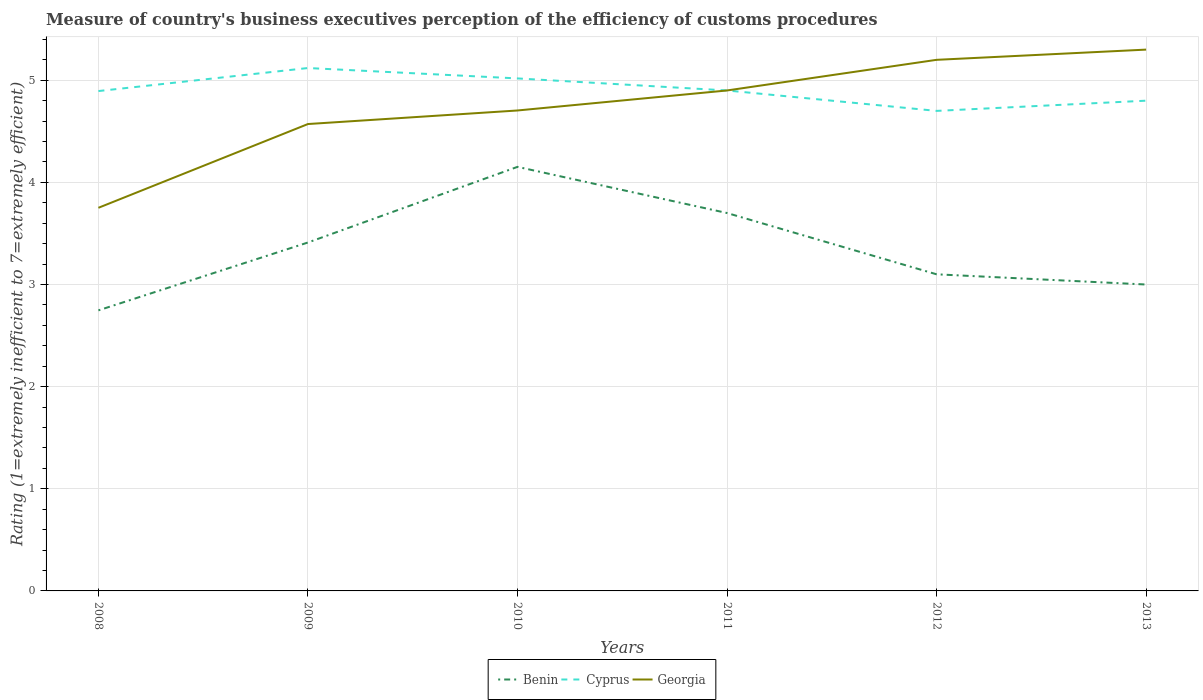Does the line corresponding to Georgia intersect with the line corresponding to Benin?
Your response must be concise. No. Across all years, what is the maximum rating of the efficiency of customs procedure in Benin?
Give a very brief answer. 2.75. In which year was the rating of the efficiency of customs procedure in Benin maximum?
Provide a short and direct response. 2008. What is the total rating of the efficiency of customs procedure in Cyprus in the graph?
Give a very brief answer. 0.32. What is the difference between the highest and the second highest rating of the efficiency of customs procedure in Georgia?
Give a very brief answer. 1.55. What is the difference between the highest and the lowest rating of the efficiency of customs procedure in Cyprus?
Your answer should be compact. 2. Is the rating of the efficiency of customs procedure in Cyprus strictly greater than the rating of the efficiency of customs procedure in Benin over the years?
Provide a short and direct response. No. How many lines are there?
Your response must be concise. 3. How many years are there in the graph?
Offer a terse response. 6. Are the values on the major ticks of Y-axis written in scientific E-notation?
Keep it short and to the point. No. Does the graph contain any zero values?
Offer a very short reply. No. What is the title of the graph?
Offer a terse response. Measure of country's business executives perception of the efficiency of customs procedures. Does "Nepal" appear as one of the legend labels in the graph?
Your answer should be compact. No. What is the label or title of the X-axis?
Provide a succinct answer. Years. What is the label or title of the Y-axis?
Offer a terse response. Rating (1=extremely inefficient to 7=extremely efficient). What is the Rating (1=extremely inefficient to 7=extremely efficient) of Benin in 2008?
Your answer should be compact. 2.75. What is the Rating (1=extremely inefficient to 7=extremely efficient) in Cyprus in 2008?
Keep it short and to the point. 4.89. What is the Rating (1=extremely inefficient to 7=extremely efficient) in Georgia in 2008?
Make the answer very short. 3.75. What is the Rating (1=extremely inefficient to 7=extremely efficient) of Benin in 2009?
Provide a short and direct response. 3.41. What is the Rating (1=extremely inefficient to 7=extremely efficient) in Cyprus in 2009?
Keep it short and to the point. 5.12. What is the Rating (1=extremely inefficient to 7=extremely efficient) of Georgia in 2009?
Provide a short and direct response. 4.57. What is the Rating (1=extremely inefficient to 7=extremely efficient) of Benin in 2010?
Give a very brief answer. 4.15. What is the Rating (1=extremely inefficient to 7=extremely efficient) in Cyprus in 2010?
Offer a terse response. 5.02. What is the Rating (1=extremely inefficient to 7=extremely efficient) of Georgia in 2010?
Your answer should be compact. 4.7. What is the Rating (1=extremely inefficient to 7=extremely efficient) in Benin in 2011?
Make the answer very short. 3.7. What is the Rating (1=extremely inefficient to 7=extremely efficient) in Georgia in 2011?
Give a very brief answer. 4.9. What is the Rating (1=extremely inefficient to 7=extremely efficient) in Benin in 2012?
Provide a short and direct response. 3.1. What is the Rating (1=extremely inefficient to 7=extremely efficient) in Georgia in 2012?
Ensure brevity in your answer.  5.2. What is the Rating (1=extremely inefficient to 7=extremely efficient) of Georgia in 2013?
Offer a very short reply. 5.3. Across all years, what is the maximum Rating (1=extremely inefficient to 7=extremely efficient) of Benin?
Make the answer very short. 4.15. Across all years, what is the maximum Rating (1=extremely inefficient to 7=extremely efficient) in Cyprus?
Keep it short and to the point. 5.12. Across all years, what is the maximum Rating (1=extremely inefficient to 7=extremely efficient) of Georgia?
Give a very brief answer. 5.3. Across all years, what is the minimum Rating (1=extremely inefficient to 7=extremely efficient) of Benin?
Keep it short and to the point. 2.75. Across all years, what is the minimum Rating (1=extremely inefficient to 7=extremely efficient) of Cyprus?
Give a very brief answer. 4.7. Across all years, what is the minimum Rating (1=extremely inefficient to 7=extremely efficient) of Georgia?
Make the answer very short. 3.75. What is the total Rating (1=extremely inefficient to 7=extremely efficient) of Benin in the graph?
Give a very brief answer. 20.11. What is the total Rating (1=extremely inefficient to 7=extremely efficient) in Cyprus in the graph?
Provide a short and direct response. 29.43. What is the total Rating (1=extremely inefficient to 7=extremely efficient) of Georgia in the graph?
Your answer should be very brief. 28.43. What is the difference between the Rating (1=extremely inefficient to 7=extremely efficient) of Benin in 2008 and that in 2009?
Offer a terse response. -0.66. What is the difference between the Rating (1=extremely inefficient to 7=extremely efficient) in Cyprus in 2008 and that in 2009?
Offer a very short reply. -0.23. What is the difference between the Rating (1=extremely inefficient to 7=extremely efficient) in Georgia in 2008 and that in 2009?
Make the answer very short. -0.82. What is the difference between the Rating (1=extremely inefficient to 7=extremely efficient) of Benin in 2008 and that in 2010?
Your answer should be compact. -1.41. What is the difference between the Rating (1=extremely inefficient to 7=extremely efficient) in Cyprus in 2008 and that in 2010?
Provide a short and direct response. -0.12. What is the difference between the Rating (1=extremely inefficient to 7=extremely efficient) in Georgia in 2008 and that in 2010?
Provide a short and direct response. -0.95. What is the difference between the Rating (1=extremely inefficient to 7=extremely efficient) of Benin in 2008 and that in 2011?
Your answer should be very brief. -0.95. What is the difference between the Rating (1=extremely inefficient to 7=extremely efficient) of Cyprus in 2008 and that in 2011?
Offer a terse response. -0.01. What is the difference between the Rating (1=extremely inefficient to 7=extremely efficient) of Georgia in 2008 and that in 2011?
Your response must be concise. -1.15. What is the difference between the Rating (1=extremely inefficient to 7=extremely efficient) in Benin in 2008 and that in 2012?
Offer a terse response. -0.35. What is the difference between the Rating (1=extremely inefficient to 7=extremely efficient) of Cyprus in 2008 and that in 2012?
Offer a very short reply. 0.19. What is the difference between the Rating (1=extremely inefficient to 7=extremely efficient) of Georgia in 2008 and that in 2012?
Your response must be concise. -1.45. What is the difference between the Rating (1=extremely inefficient to 7=extremely efficient) of Benin in 2008 and that in 2013?
Provide a short and direct response. -0.25. What is the difference between the Rating (1=extremely inefficient to 7=extremely efficient) of Cyprus in 2008 and that in 2013?
Make the answer very short. 0.09. What is the difference between the Rating (1=extremely inefficient to 7=extremely efficient) of Georgia in 2008 and that in 2013?
Provide a succinct answer. -1.55. What is the difference between the Rating (1=extremely inefficient to 7=extremely efficient) in Benin in 2009 and that in 2010?
Provide a short and direct response. -0.74. What is the difference between the Rating (1=extremely inefficient to 7=extremely efficient) in Cyprus in 2009 and that in 2010?
Make the answer very short. 0.1. What is the difference between the Rating (1=extremely inefficient to 7=extremely efficient) of Georgia in 2009 and that in 2010?
Your answer should be very brief. -0.13. What is the difference between the Rating (1=extremely inefficient to 7=extremely efficient) in Benin in 2009 and that in 2011?
Your answer should be very brief. -0.29. What is the difference between the Rating (1=extremely inefficient to 7=extremely efficient) in Cyprus in 2009 and that in 2011?
Give a very brief answer. 0.22. What is the difference between the Rating (1=extremely inefficient to 7=extremely efficient) in Georgia in 2009 and that in 2011?
Your response must be concise. -0.33. What is the difference between the Rating (1=extremely inefficient to 7=extremely efficient) in Benin in 2009 and that in 2012?
Ensure brevity in your answer.  0.31. What is the difference between the Rating (1=extremely inefficient to 7=extremely efficient) in Cyprus in 2009 and that in 2012?
Keep it short and to the point. 0.42. What is the difference between the Rating (1=extremely inefficient to 7=extremely efficient) in Georgia in 2009 and that in 2012?
Your answer should be very brief. -0.63. What is the difference between the Rating (1=extremely inefficient to 7=extremely efficient) of Benin in 2009 and that in 2013?
Keep it short and to the point. 0.41. What is the difference between the Rating (1=extremely inefficient to 7=extremely efficient) of Cyprus in 2009 and that in 2013?
Offer a terse response. 0.32. What is the difference between the Rating (1=extremely inefficient to 7=extremely efficient) of Georgia in 2009 and that in 2013?
Make the answer very short. -0.73. What is the difference between the Rating (1=extremely inefficient to 7=extremely efficient) in Benin in 2010 and that in 2011?
Offer a very short reply. 0.45. What is the difference between the Rating (1=extremely inefficient to 7=extremely efficient) in Cyprus in 2010 and that in 2011?
Your response must be concise. 0.12. What is the difference between the Rating (1=extremely inefficient to 7=extremely efficient) of Georgia in 2010 and that in 2011?
Your answer should be very brief. -0.2. What is the difference between the Rating (1=extremely inefficient to 7=extremely efficient) in Benin in 2010 and that in 2012?
Ensure brevity in your answer.  1.05. What is the difference between the Rating (1=extremely inefficient to 7=extremely efficient) in Cyprus in 2010 and that in 2012?
Your answer should be compact. 0.32. What is the difference between the Rating (1=extremely inefficient to 7=extremely efficient) of Georgia in 2010 and that in 2012?
Keep it short and to the point. -0.5. What is the difference between the Rating (1=extremely inefficient to 7=extremely efficient) of Benin in 2010 and that in 2013?
Provide a succinct answer. 1.15. What is the difference between the Rating (1=extremely inefficient to 7=extremely efficient) in Cyprus in 2010 and that in 2013?
Your answer should be compact. 0.22. What is the difference between the Rating (1=extremely inefficient to 7=extremely efficient) in Georgia in 2010 and that in 2013?
Offer a very short reply. -0.6. What is the difference between the Rating (1=extremely inefficient to 7=extremely efficient) of Cyprus in 2011 and that in 2013?
Your answer should be compact. 0.1. What is the difference between the Rating (1=extremely inefficient to 7=extremely efficient) in Georgia in 2011 and that in 2013?
Offer a terse response. -0.4. What is the difference between the Rating (1=extremely inefficient to 7=extremely efficient) in Benin in 2012 and that in 2013?
Make the answer very short. 0.1. What is the difference between the Rating (1=extremely inefficient to 7=extremely efficient) in Cyprus in 2012 and that in 2013?
Give a very brief answer. -0.1. What is the difference between the Rating (1=extremely inefficient to 7=extremely efficient) of Georgia in 2012 and that in 2013?
Give a very brief answer. -0.1. What is the difference between the Rating (1=extremely inefficient to 7=extremely efficient) of Benin in 2008 and the Rating (1=extremely inefficient to 7=extremely efficient) of Cyprus in 2009?
Ensure brevity in your answer.  -2.37. What is the difference between the Rating (1=extremely inefficient to 7=extremely efficient) of Benin in 2008 and the Rating (1=extremely inefficient to 7=extremely efficient) of Georgia in 2009?
Your response must be concise. -1.82. What is the difference between the Rating (1=extremely inefficient to 7=extremely efficient) in Cyprus in 2008 and the Rating (1=extremely inefficient to 7=extremely efficient) in Georgia in 2009?
Offer a very short reply. 0.32. What is the difference between the Rating (1=extremely inefficient to 7=extremely efficient) in Benin in 2008 and the Rating (1=extremely inefficient to 7=extremely efficient) in Cyprus in 2010?
Offer a very short reply. -2.27. What is the difference between the Rating (1=extremely inefficient to 7=extremely efficient) of Benin in 2008 and the Rating (1=extremely inefficient to 7=extremely efficient) of Georgia in 2010?
Make the answer very short. -1.96. What is the difference between the Rating (1=extremely inefficient to 7=extremely efficient) in Cyprus in 2008 and the Rating (1=extremely inefficient to 7=extremely efficient) in Georgia in 2010?
Ensure brevity in your answer.  0.19. What is the difference between the Rating (1=extremely inefficient to 7=extremely efficient) of Benin in 2008 and the Rating (1=extremely inefficient to 7=extremely efficient) of Cyprus in 2011?
Give a very brief answer. -2.15. What is the difference between the Rating (1=extremely inefficient to 7=extremely efficient) in Benin in 2008 and the Rating (1=extremely inefficient to 7=extremely efficient) in Georgia in 2011?
Provide a short and direct response. -2.15. What is the difference between the Rating (1=extremely inefficient to 7=extremely efficient) of Cyprus in 2008 and the Rating (1=extremely inefficient to 7=extremely efficient) of Georgia in 2011?
Make the answer very short. -0.01. What is the difference between the Rating (1=extremely inefficient to 7=extremely efficient) of Benin in 2008 and the Rating (1=extremely inefficient to 7=extremely efficient) of Cyprus in 2012?
Offer a very short reply. -1.95. What is the difference between the Rating (1=extremely inefficient to 7=extremely efficient) of Benin in 2008 and the Rating (1=extremely inefficient to 7=extremely efficient) of Georgia in 2012?
Make the answer very short. -2.45. What is the difference between the Rating (1=extremely inefficient to 7=extremely efficient) of Cyprus in 2008 and the Rating (1=extremely inefficient to 7=extremely efficient) of Georgia in 2012?
Your answer should be compact. -0.31. What is the difference between the Rating (1=extremely inefficient to 7=extremely efficient) in Benin in 2008 and the Rating (1=extremely inefficient to 7=extremely efficient) in Cyprus in 2013?
Offer a terse response. -2.05. What is the difference between the Rating (1=extremely inefficient to 7=extremely efficient) in Benin in 2008 and the Rating (1=extremely inefficient to 7=extremely efficient) in Georgia in 2013?
Give a very brief answer. -2.55. What is the difference between the Rating (1=extremely inefficient to 7=extremely efficient) in Cyprus in 2008 and the Rating (1=extremely inefficient to 7=extremely efficient) in Georgia in 2013?
Make the answer very short. -0.41. What is the difference between the Rating (1=extremely inefficient to 7=extremely efficient) of Benin in 2009 and the Rating (1=extremely inefficient to 7=extremely efficient) of Cyprus in 2010?
Give a very brief answer. -1.61. What is the difference between the Rating (1=extremely inefficient to 7=extremely efficient) of Benin in 2009 and the Rating (1=extremely inefficient to 7=extremely efficient) of Georgia in 2010?
Offer a very short reply. -1.29. What is the difference between the Rating (1=extremely inefficient to 7=extremely efficient) in Cyprus in 2009 and the Rating (1=extremely inefficient to 7=extremely efficient) in Georgia in 2010?
Give a very brief answer. 0.42. What is the difference between the Rating (1=extremely inefficient to 7=extremely efficient) in Benin in 2009 and the Rating (1=extremely inefficient to 7=extremely efficient) in Cyprus in 2011?
Offer a terse response. -1.49. What is the difference between the Rating (1=extremely inefficient to 7=extremely efficient) in Benin in 2009 and the Rating (1=extremely inefficient to 7=extremely efficient) in Georgia in 2011?
Offer a terse response. -1.49. What is the difference between the Rating (1=extremely inefficient to 7=extremely efficient) in Cyprus in 2009 and the Rating (1=extremely inefficient to 7=extremely efficient) in Georgia in 2011?
Give a very brief answer. 0.22. What is the difference between the Rating (1=extremely inefficient to 7=extremely efficient) in Benin in 2009 and the Rating (1=extremely inefficient to 7=extremely efficient) in Cyprus in 2012?
Offer a very short reply. -1.29. What is the difference between the Rating (1=extremely inefficient to 7=extremely efficient) of Benin in 2009 and the Rating (1=extremely inefficient to 7=extremely efficient) of Georgia in 2012?
Provide a short and direct response. -1.79. What is the difference between the Rating (1=extremely inefficient to 7=extremely efficient) of Cyprus in 2009 and the Rating (1=extremely inefficient to 7=extremely efficient) of Georgia in 2012?
Provide a short and direct response. -0.08. What is the difference between the Rating (1=extremely inefficient to 7=extremely efficient) in Benin in 2009 and the Rating (1=extremely inefficient to 7=extremely efficient) in Cyprus in 2013?
Ensure brevity in your answer.  -1.39. What is the difference between the Rating (1=extremely inefficient to 7=extremely efficient) in Benin in 2009 and the Rating (1=extremely inefficient to 7=extremely efficient) in Georgia in 2013?
Your answer should be very brief. -1.89. What is the difference between the Rating (1=extremely inefficient to 7=extremely efficient) of Cyprus in 2009 and the Rating (1=extremely inefficient to 7=extremely efficient) of Georgia in 2013?
Offer a very short reply. -0.18. What is the difference between the Rating (1=extremely inefficient to 7=extremely efficient) in Benin in 2010 and the Rating (1=extremely inefficient to 7=extremely efficient) in Cyprus in 2011?
Offer a very short reply. -0.75. What is the difference between the Rating (1=extremely inefficient to 7=extremely efficient) of Benin in 2010 and the Rating (1=extremely inefficient to 7=extremely efficient) of Georgia in 2011?
Your response must be concise. -0.75. What is the difference between the Rating (1=extremely inefficient to 7=extremely efficient) in Cyprus in 2010 and the Rating (1=extremely inefficient to 7=extremely efficient) in Georgia in 2011?
Offer a very short reply. 0.12. What is the difference between the Rating (1=extremely inefficient to 7=extremely efficient) of Benin in 2010 and the Rating (1=extremely inefficient to 7=extremely efficient) of Cyprus in 2012?
Provide a short and direct response. -0.55. What is the difference between the Rating (1=extremely inefficient to 7=extremely efficient) in Benin in 2010 and the Rating (1=extremely inefficient to 7=extremely efficient) in Georgia in 2012?
Your answer should be compact. -1.05. What is the difference between the Rating (1=extremely inefficient to 7=extremely efficient) of Cyprus in 2010 and the Rating (1=extremely inefficient to 7=extremely efficient) of Georgia in 2012?
Your response must be concise. -0.18. What is the difference between the Rating (1=extremely inefficient to 7=extremely efficient) in Benin in 2010 and the Rating (1=extremely inefficient to 7=extremely efficient) in Cyprus in 2013?
Make the answer very short. -0.65. What is the difference between the Rating (1=extremely inefficient to 7=extremely efficient) in Benin in 2010 and the Rating (1=extremely inefficient to 7=extremely efficient) in Georgia in 2013?
Give a very brief answer. -1.15. What is the difference between the Rating (1=extremely inefficient to 7=extremely efficient) in Cyprus in 2010 and the Rating (1=extremely inefficient to 7=extremely efficient) in Georgia in 2013?
Your response must be concise. -0.28. What is the difference between the Rating (1=extremely inefficient to 7=extremely efficient) of Benin in 2011 and the Rating (1=extremely inefficient to 7=extremely efficient) of Georgia in 2012?
Your response must be concise. -1.5. What is the difference between the Rating (1=extremely inefficient to 7=extremely efficient) in Cyprus in 2011 and the Rating (1=extremely inefficient to 7=extremely efficient) in Georgia in 2013?
Your response must be concise. -0.4. What is the difference between the Rating (1=extremely inefficient to 7=extremely efficient) of Benin in 2012 and the Rating (1=extremely inefficient to 7=extremely efficient) of Georgia in 2013?
Your answer should be compact. -2.2. What is the average Rating (1=extremely inefficient to 7=extremely efficient) of Benin per year?
Your answer should be compact. 3.35. What is the average Rating (1=extremely inefficient to 7=extremely efficient) of Cyprus per year?
Provide a short and direct response. 4.91. What is the average Rating (1=extremely inefficient to 7=extremely efficient) of Georgia per year?
Give a very brief answer. 4.74. In the year 2008, what is the difference between the Rating (1=extremely inefficient to 7=extremely efficient) in Benin and Rating (1=extremely inefficient to 7=extremely efficient) in Cyprus?
Offer a terse response. -2.15. In the year 2008, what is the difference between the Rating (1=extremely inefficient to 7=extremely efficient) in Benin and Rating (1=extremely inefficient to 7=extremely efficient) in Georgia?
Offer a very short reply. -1. In the year 2009, what is the difference between the Rating (1=extremely inefficient to 7=extremely efficient) of Benin and Rating (1=extremely inefficient to 7=extremely efficient) of Cyprus?
Your answer should be compact. -1.71. In the year 2009, what is the difference between the Rating (1=extremely inefficient to 7=extremely efficient) in Benin and Rating (1=extremely inefficient to 7=extremely efficient) in Georgia?
Offer a very short reply. -1.16. In the year 2009, what is the difference between the Rating (1=extremely inefficient to 7=extremely efficient) of Cyprus and Rating (1=extremely inefficient to 7=extremely efficient) of Georgia?
Keep it short and to the point. 0.55. In the year 2010, what is the difference between the Rating (1=extremely inefficient to 7=extremely efficient) of Benin and Rating (1=extremely inefficient to 7=extremely efficient) of Cyprus?
Provide a succinct answer. -0.87. In the year 2010, what is the difference between the Rating (1=extremely inefficient to 7=extremely efficient) in Benin and Rating (1=extremely inefficient to 7=extremely efficient) in Georgia?
Offer a terse response. -0.55. In the year 2010, what is the difference between the Rating (1=extremely inefficient to 7=extremely efficient) of Cyprus and Rating (1=extremely inefficient to 7=extremely efficient) of Georgia?
Give a very brief answer. 0.31. In the year 2011, what is the difference between the Rating (1=extremely inefficient to 7=extremely efficient) in Cyprus and Rating (1=extremely inefficient to 7=extremely efficient) in Georgia?
Your answer should be very brief. 0. In the year 2012, what is the difference between the Rating (1=extremely inefficient to 7=extremely efficient) of Benin and Rating (1=extremely inefficient to 7=extremely efficient) of Cyprus?
Offer a terse response. -1.6. In the year 2013, what is the difference between the Rating (1=extremely inefficient to 7=extremely efficient) in Benin and Rating (1=extremely inefficient to 7=extremely efficient) in Cyprus?
Offer a terse response. -1.8. In the year 2013, what is the difference between the Rating (1=extremely inefficient to 7=extremely efficient) of Cyprus and Rating (1=extremely inefficient to 7=extremely efficient) of Georgia?
Ensure brevity in your answer.  -0.5. What is the ratio of the Rating (1=extremely inefficient to 7=extremely efficient) of Benin in 2008 to that in 2009?
Keep it short and to the point. 0.81. What is the ratio of the Rating (1=extremely inefficient to 7=extremely efficient) of Cyprus in 2008 to that in 2009?
Make the answer very short. 0.96. What is the ratio of the Rating (1=extremely inefficient to 7=extremely efficient) in Georgia in 2008 to that in 2009?
Your response must be concise. 0.82. What is the ratio of the Rating (1=extremely inefficient to 7=extremely efficient) in Benin in 2008 to that in 2010?
Provide a succinct answer. 0.66. What is the ratio of the Rating (1=extremely inefficient to 7=extremely efficient) of Cyprus in 2008 to that in 2010?
Provide a short and direct response. 0.98. What is the ratio of the Rating (1=extremely inefficient to 7=extremely efficient) of Georgia in 2008 to that in 2010?
Make the answer very short. 0.8. What is the ratio of the Rating (1=extremely inefficient to 7=extremely efficient) of Benin in 2008 to that in 2011?
Your answer should be compact. 0.74. What is the ratio of the Rating (1=extremely inefficient to 7=extremely efficient) in Georgia in 2008 to that in 2011?
Give a very brief answer. 0.77. What is the ratio of the Rating (1=extremely inefficient to 7=extremely efficient) of Benin in 2008 to that in 2012?
Offer a very short reply. 0.89. What is the ratio of the Rating (1=extremely inefficient to 7=extremely efficient) in Cyprus in 2008 to that in 2012?
Offer a very short reply. 1.04. What is the ratio of the Rating (1=extremely inefficient to 7=extremely efficient) in Georgia in 2008 to that in 2012?
Keep it short and to the point. 0.72. What is the ratio of the Rating (1=extremely inefficient to 7=extremely efficient) of Benin in 2008 to that in 2013?
Provide a succinct answer. 0.92. What is the ratio of the Rating (1=extremely inefficient to 7=extremely efficient) in Cyprus in 2008 to that in 2013?
Your answer should be very brief. 1.02. What is the ratio of the Rating (1=extremely inefficient to 7=extremely efficient) in Georgia in 2008 to that in 2013?
Your answer should be compact. 0.71. What is the ratio of the Rating (1=extremely inefficient to 7=extremely efficient) in Benin in 2009 to that in 2010?
Give a very brief answer. 0.82. What is the ratio of the Rating (1=extremely inefficient to 7=extremely efficient) in Cyprus in 2009 to that in 2010?
Keep it short and to the point. 1.02. What is the ratio of the Rating (1=extremely inefficient to 7=extremely efficient) in Georgia in 2009 to that in 2010?
Keep it short and to the point. 0.97. What is the ratio of the Rating (1=extremely inefficient to 7=extremely efficient) in Benin in 2009 to that in 2011?
Make the answer very short. 0.92. What is the ratio of the Rating (1=extremely inefficient to 7=extremely efficient) of Cyprus in 2009 to that in 2011?
Provide a succinct answer. 1.04. What is the ratio of the Rating (1=extremely inefficient to 7=extremely efficient) in Georgia in 2009 to that in 2011?
Your answer should be very brief. 0.93. What is the ratio of the Rating (1=extremely inefficient to 7=extremely efficient) in Benin in 2009 to that in 2012?
Keep it short and to the point. 1.1. What is the ratio of the Rating (1=extremely inefficient to 7=extremely efficient) in Cyprus in 2009 to that in 2012?
Provide a succinct answer. 1.09. What is the ratio of the Rating (1=extremely inefficient to 7=extremely efficient) of Georgia in 2009 to that in 2012?
Your response must be concise. 0.88. What is the ratio of the Rating (1=extremely inefficient to 7=extremely efficient) in Benin in 2009 to that in 2013?
Provide a succinct answer. 1.14. What is the ratio of the Rating (1=extremely inefficient to 7=extremely efficient) in Cyprus in 2009 to that in 2013?
Ensure brevity in your answer.  1.07. What is the ratio of the Rating (1=extremely inefficient to 7=extremely efficient) of Georgia in 2009 to that in 2013?
Offer a terse response. 0.86. What is the ratio of the Rating (1=extremely inefficient to 7=extremely efficient) of Benin in 2010 to that in 2011?
Ensure brevity in your answer.  1.12. What is the ratio of the Rating (1=extremely inefficient to 7=extremely efficient) in Cyprus in 2010 to that in 2011?
Your response must be concise. 1.02. What is the ratio of the Rating (1=extremely inefficient to 7=extremely efficient) in Benin in 2010 to that in 2012?
Your response must be concise. 1.34. What is the ratio of the Rating (1=extremely inefficient to 7=extremely efficient) of Cyprus in 2010 to that in 2012?
Ensure brevity in your answer.  1.07. What is the ratio of the Rating (1=extremely inefficient to 7=extremely efficient) of Georgia in 2010 to that in 2012?
Your answer should be very brief. 0.9. What is the ratio of the Rating (1=extremely inefficient to 7=extremely efficient) of Benin in 2010 to that in 2013?
Provide a short and direct response. 1.38. What is the ratio of the Rating (1=extremely inefficient to 7=extremely efficient) in Cyprus in 2010 to that in 2013?
Your answer should be compact. 1.05. What is the ratio of the Rating (1=extremely inefficient to 7=extremely efficient) in Georgia in 2010 to that in 2013?
Your response must be concise. 0.89. What is the ratio of the Rating (1=extremely inefficient to 7=extremely efficient) in Benin in 2011 to that in 2012?
Make the answer very short. 1.19. What is the ratio of the Rating (1=extremely inefficient to 7=extremely efficient) of Cyprus in 2011 to that in 2012?
Your response must be concise. 1.04. What is the ratio of the Rating (1=extremely inefficient to 7=extremely efficient) in Georgia in 2011 to that in 2012?
Your response must be concise. 0.94. What is the ratio of the Rating (1=extremely inefficient to 7=extremely efficient) in Benin in 2011 to that in 2013?
Offer a terse response. 1.23. What is the ratio of the Rating (1=extremely inefficient to 7=extremely efficient) in Cyprus in 2011 to that in 2013?
Provide a succinct answer. 1.02. What is the ratio of the Rating (1=extremely inefficient to 7=extremely efficient) in Georgia in 2011 to that in 2013?
Offer a terse response. 0.92. What is the ratio of the Rating (1=extremely inefficient to 7=extremely efficient) in Cyprus in 2012 to that in 2013?
Provide a short and direct response. 0.98. What is the ratio of the Rating (1=extremely inefficient to 7=extremely efficient) in Georgia in 2012 to that in 2013?
Make the answer very short. 0.98. What is the difference between the highest and the second highest Rating (1=extremely inefficient to 7=extremely efficient) in Benin?
Provide a short and direct response. 0.45. What is the difference between the highest and the second highest Rating (1=extremely inefficient to 7=extremely efficient) in Cyprus?
Provide a succinct answer. 0.1. What is the difference between the highest and the lowest Rating (1=extremely inefficient to 7=extremely efficient) in Benin?
Keep it short and to the point. 1.41. What is the difference between the highest and the lowest Rating (1=extremely inefficient to 7=extremely efficient) of Cyprus?
Provide a short and direct response. 0.42. What is the difference between the highest and the lowest Rating (1=extremely inefficient to 7=extremely efficient) in Georgia?
Make the answer very short. 1.55. 